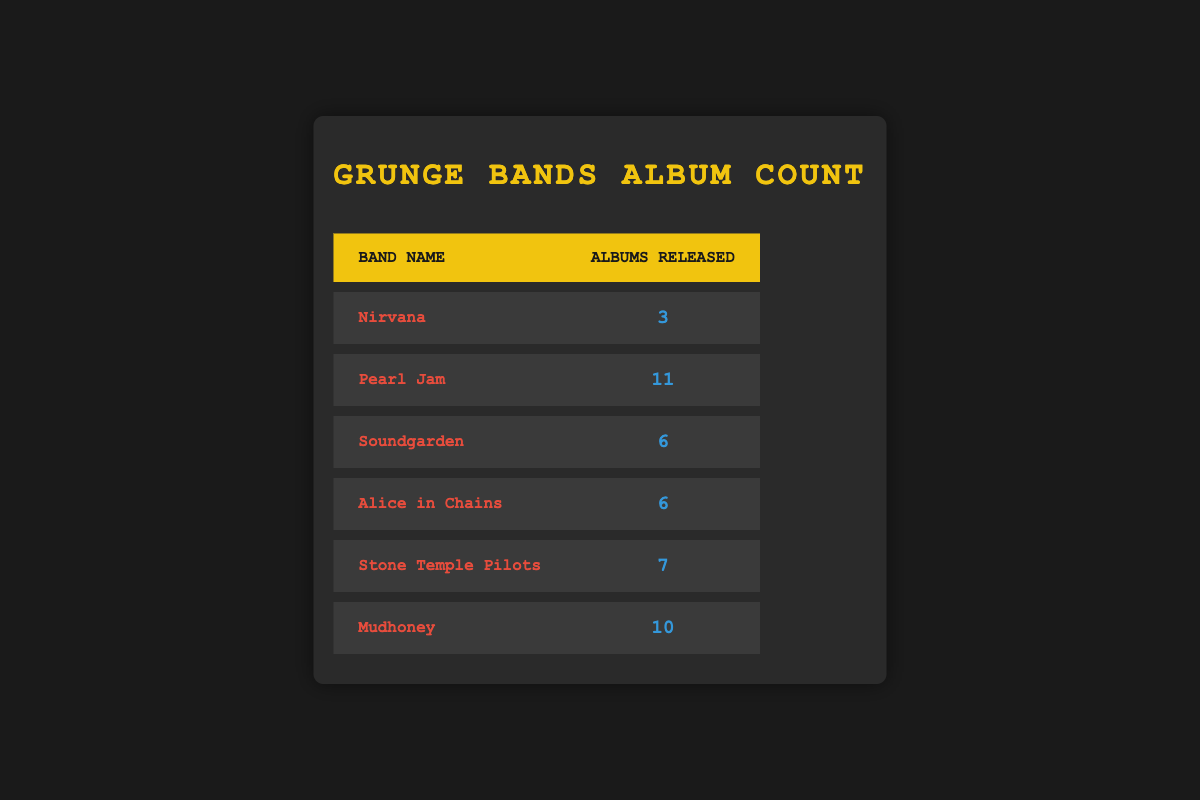What is the total number of albums released by Nirvana? The table shows that Nirvana has released 3 albums.
Answer: 3 Which band has released the most albums? By comparing the number of albums released by each band in the table, Pearl Jam has the highest count with 11 albums.
Answer: Pearl Jam How many albums did Soundgarden and Alice in Chains release combined? Adding the albums for Soundgarden (6) and Alice in Chains (6): 6 + 6 = 12.
Answer: 12 Is it true that Mudhoney has released more albums than Stone Temple Pilots? Mudhoney has released 10 albums, while Stone Temple Pilots has released 7. Thus, it is true that Mudhoney has more albums.
Answer: Yes What is the average number of albums released by the bands listed? To find the average, sum the albums: 3 + 11 + 6 + 6 + 7 + 10 = 43. The count of bands is 6, so the average is 43/6, which is approximately 7.17.
Answer: 7.17 How many bands have released 6 albums or more? The table shows 5 bands: Pearl Jam (11), Soundgarden (6), Alice in Chains (6), Stone Temple Pilots (7), and Mudhoney (10) have released 6 or more albums. So, the answer is 5.
Answer: 5 Has any band released exactly 10 albums? The data shows that Mudhoney has released exactly 10 albums.
Answer: Yes Which band has released fewer albums, Stone Temple Pilots or Nirvana? Nirvana has released 3 albums, and Stone Temple Pilots has released 7 albums. Since 3 is less than 7, Nirvana has released fewer albums.
Answer: Nirvana 